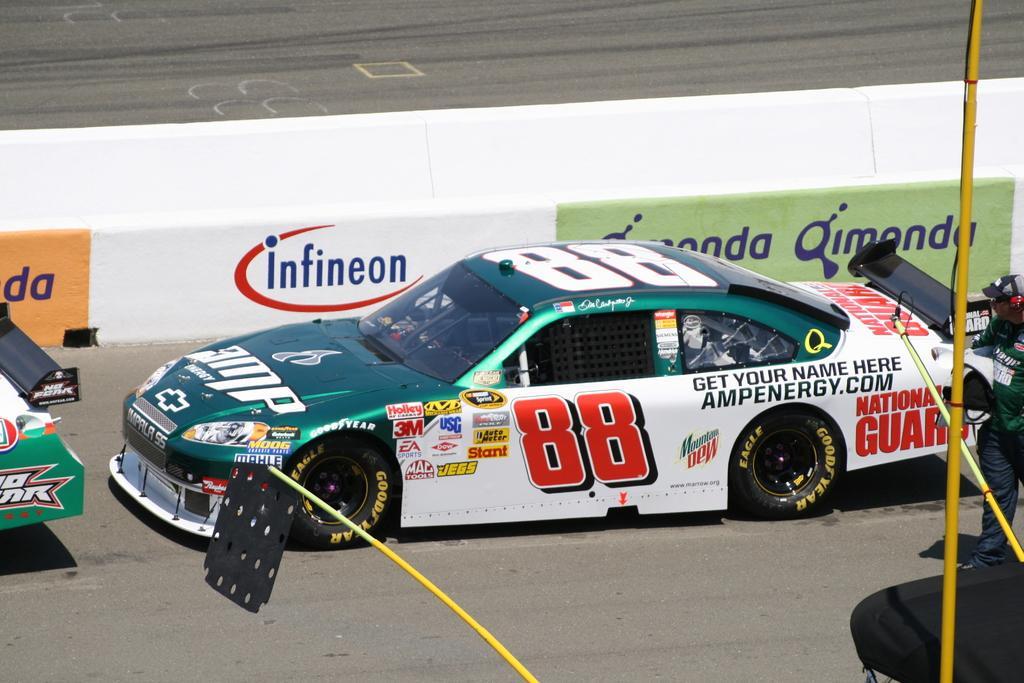Could you give a brief overview of what you see in this image? In this image we can see a car on the road, there is the windshield, there are the tires, at back here a person is standing, there is the pole. 